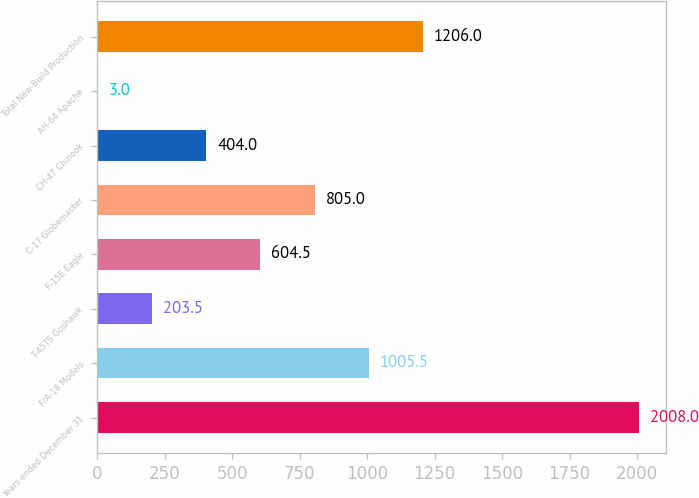Convert chart. <chart><loc_0><loc_0><loc_500><loc_500><bar_chart><fcel>Years ended December 31<fcel>F/A-18 Models<fcel>T-45TS Goshawk<fcel>F-15E Eagle<fcel>C-17 Globemaster<fcel>CH-47 Chinook<fcel>AH-64 Apache<fcel>Total New-Build Production<nl><fcel>2008<fcel>1005.5<fcel>203.5<fcel>604.5<fcel>805<fcel>404<fcel>3<fcel>1206<nl></chart> 